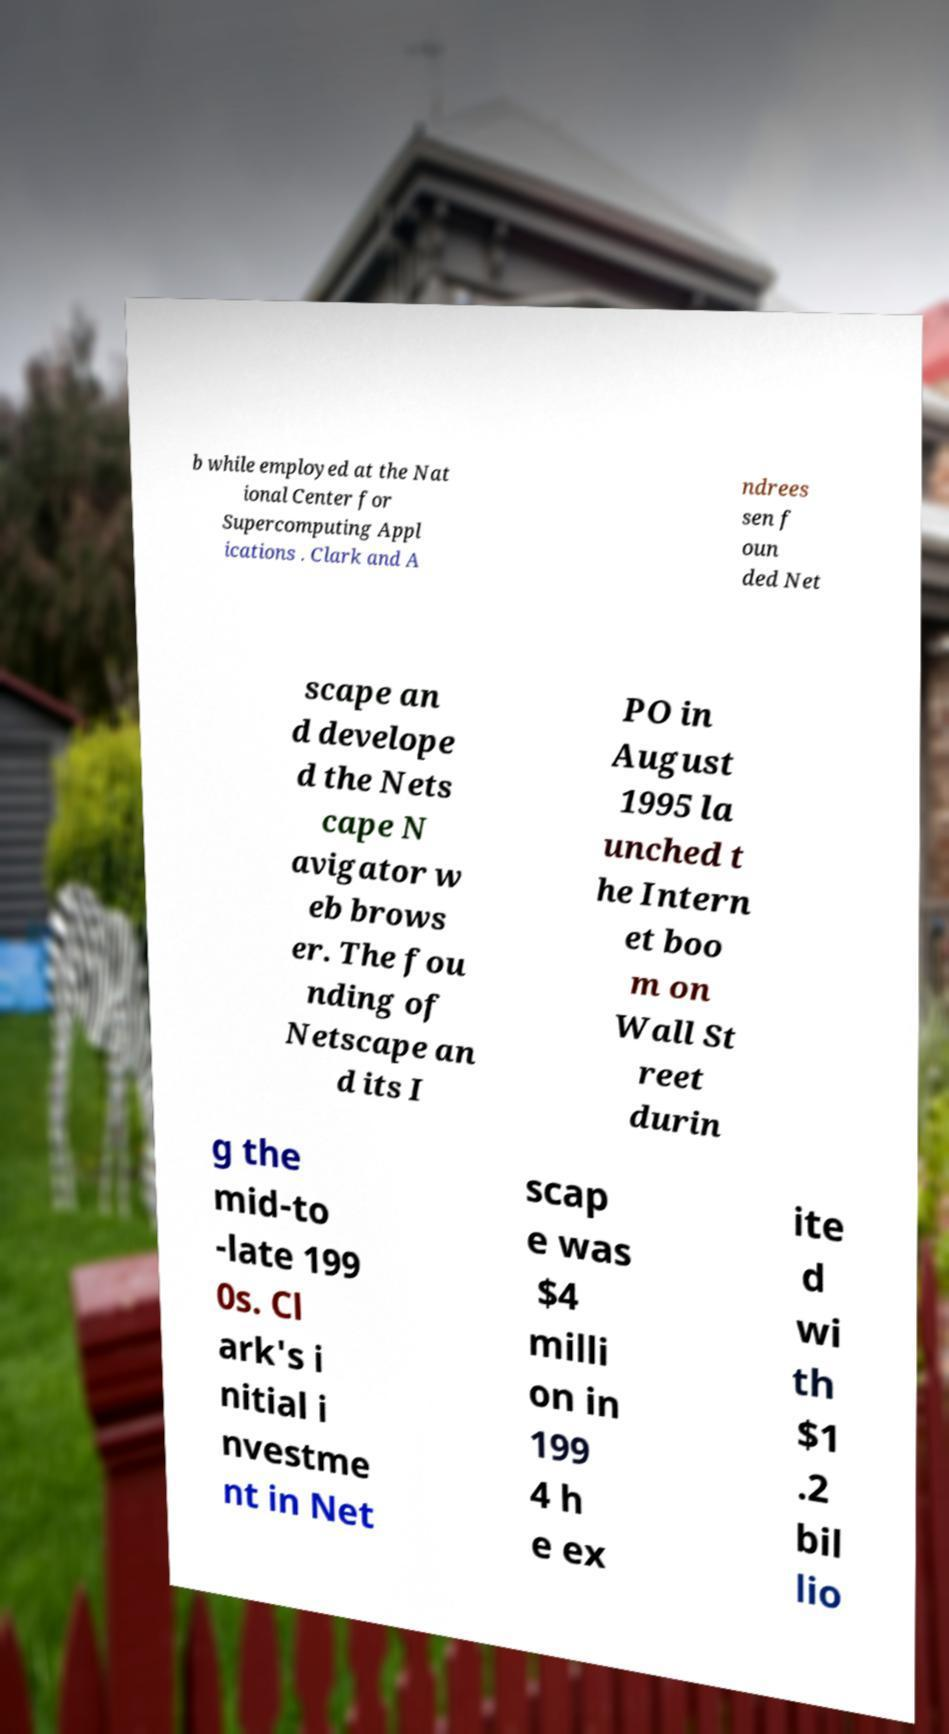I need the written content from this picture converted into text. Can you do that? b while employed at the Nat ional Center for Supercomputing Appl ications . Clark and A ndrees sen f oun ded Net scape an d develope d the Nets cape N avigator w eb brows er. The fou nding of Netscape an d its I PO in August 1995 la unched t he Intern et boo m on Wall St reet durin g the mid-to -late 199 0s. Cl ark's i nitial i nvestme nt in Net scap e was $4 milli on in 199 4 h e ex ite d wi th $1 .2 bil lio 